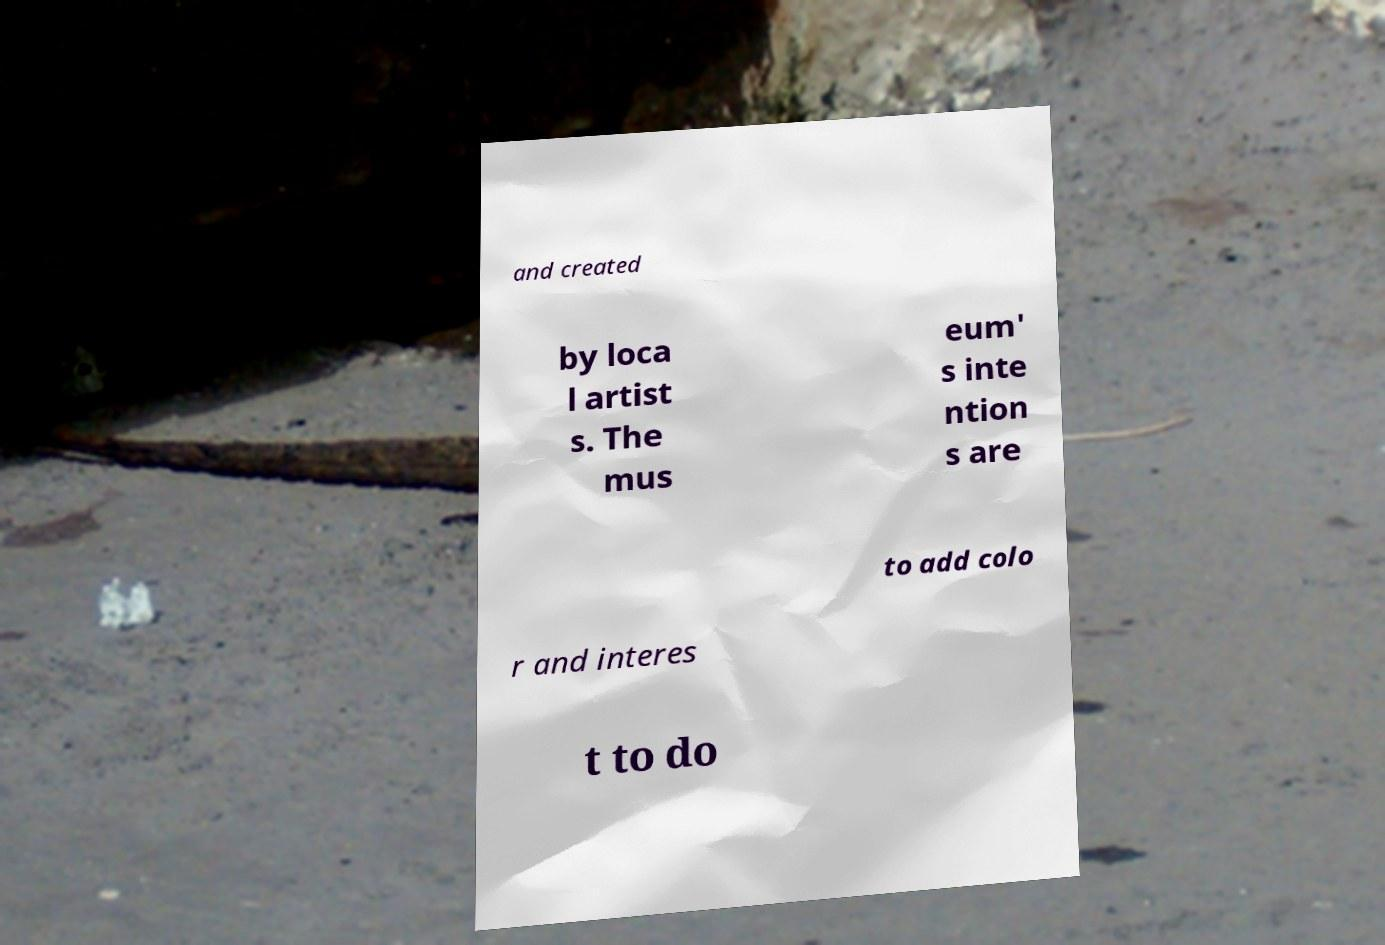Please read and relay the text visible in this image. What does it say? and created by loca l artist s. The mus eum' s inte ntion s are to add colo r and interes t to do 